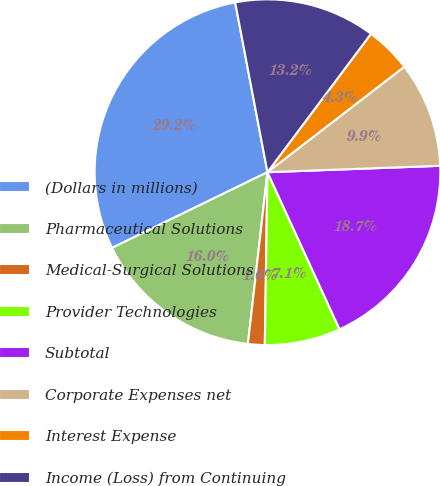Convert chart to OTSL. <chart><loc_0><loc_0><loc_500><loc_500><pie_chart><fcel>(Dollars in millions)<fcel>Pharmaceutical Solutions<fcel>Medical-Surgical Solutions<fcel>Provider Technologies<fcel>Subtotal<fcel>Corporate Expenses net<fcel>Interest Expense<fcel>Income (Loss) from Continuing<nl><fcel>29.22%<fcel>15.98%<fcel>1.56%<fcel>7.09%<fcel>18.74%<fcel>9.86%<fcel>4.33%<fcel>13.21%<nl></chart> 